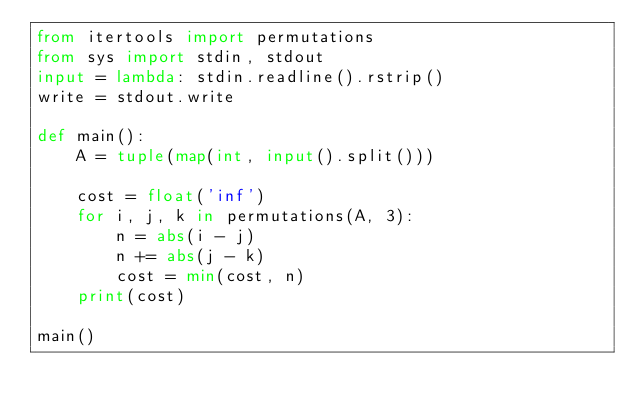<code> <loc_0><loc_0><loc_500><loc_500><_Python_>from itertools import permutations
from sys import stdin, stdout
input = lambda: stdin.readline().rstrip()
write = stdout.write

def main():
    A = tuple(map(int, input().split()))

    cost = float('inf')
    for i, j, k in permutations(A, 3):
        n = abs(i - j)
        n += abs(j - k)
        cost = min(cost, n)
    print(cost)

main()
</code> 